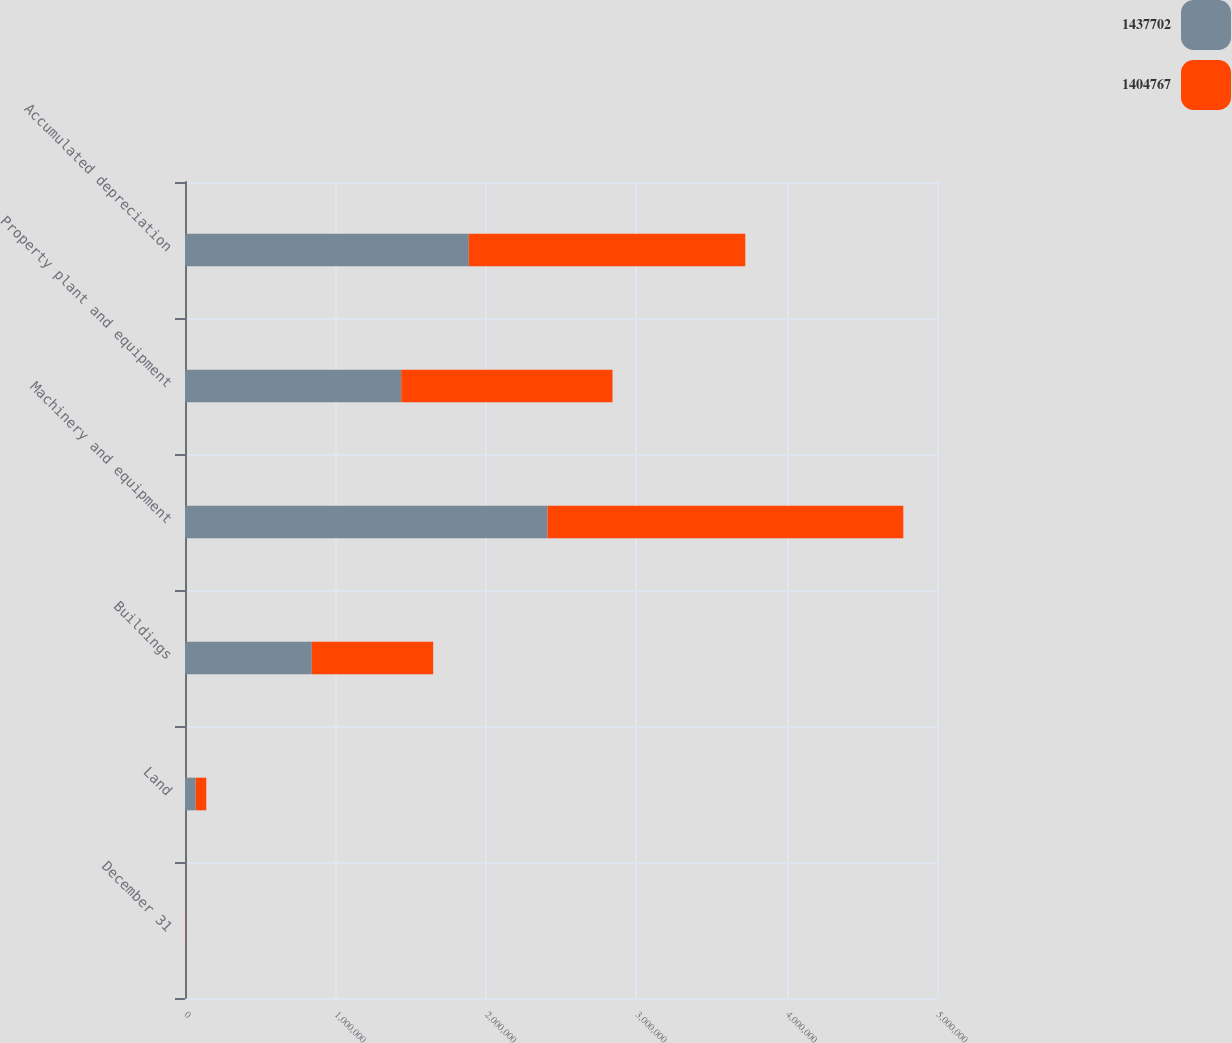Convert chart to OTSL. <chart><loc_0><loc_0><loc_500><loc_500><stacked_bar_chart><ecel><fcel>December 31<fcel>Land<fcel>Buildings<fcel>Machinery and equipment<fcel>Property plant and equipment<fcel>Accumulated depreciation<nl><fcel>1.4377e+06<fcel>2010<fcel>71060<fcel>843094<fcel>2.41061e+06<fcel>1.4377e+06<fcel>1.88706e+06<nl><fcel>1.40477e+06<fcel>2009<fcel>70388<fcel>807155<fcel>2.36532e+06<fcel>1.40477e+06<fcel>1.8381e+06<nl></chart> 